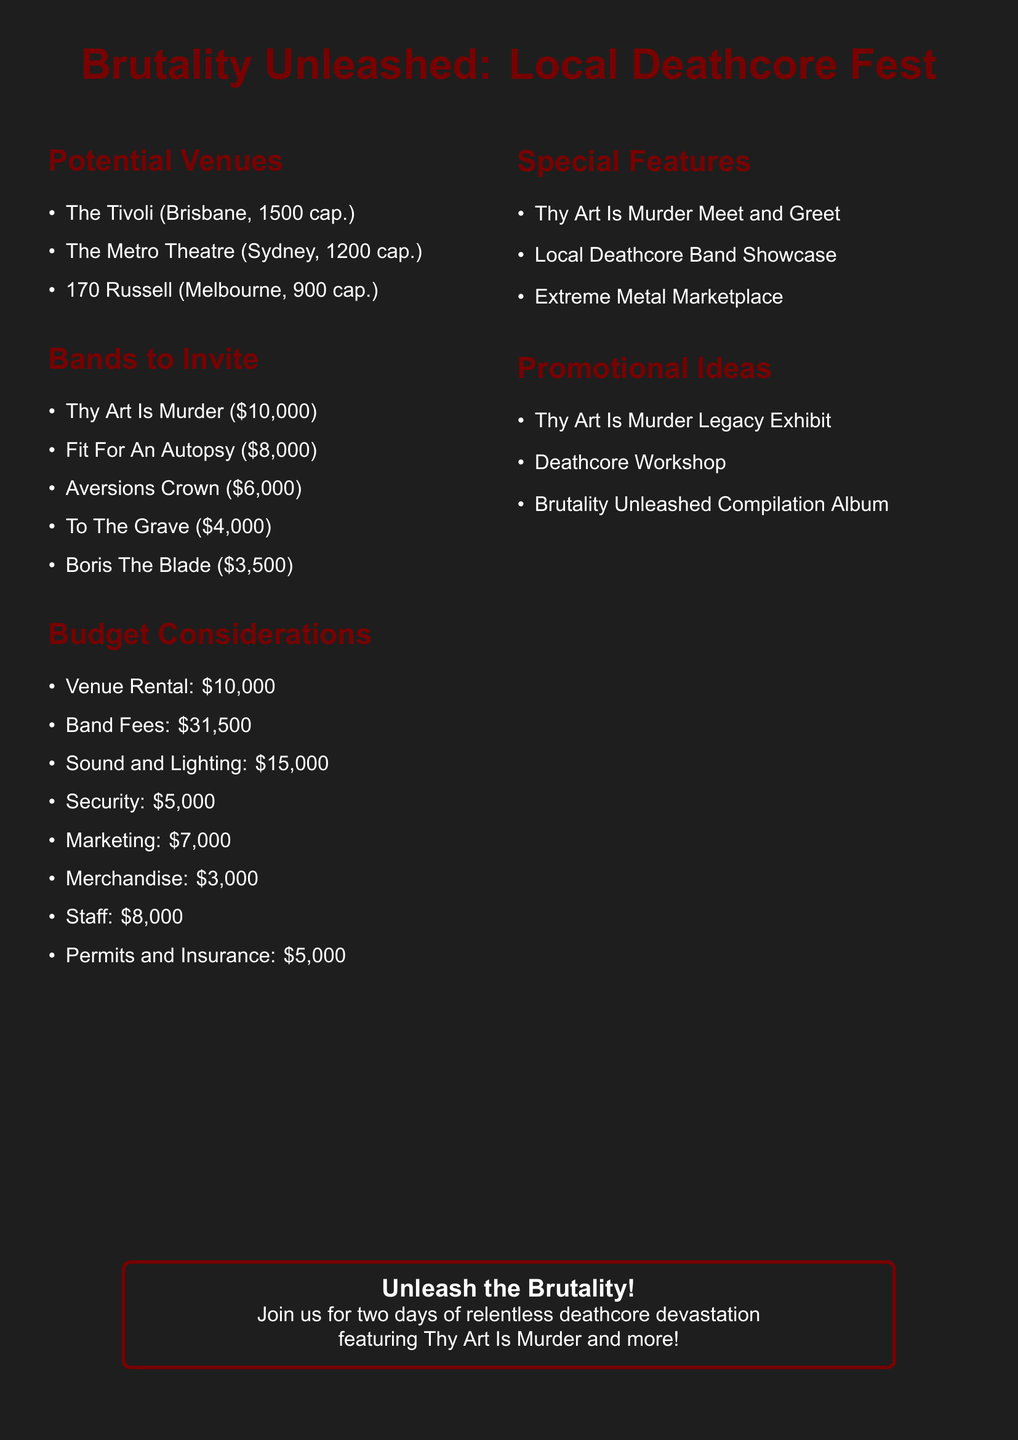What is the name of the festival? The document states the festival name is "Brutality Unleashed: Local Deathcore Fest."
Answer: Brutality Unleashed: Local Deathcore Fest How many bands are invited according to the document? The document lists five bands that are invited to the festival.
Answer: 5 What is the estimated cost of the venue rental? The budget consideration shows that the estimated cost for venue rental is $10,000.
Answer: $10,000 Which special feature is exclusive to fans? The document mentions "Thy Art Is Murder Meet and Greet" as an exclusive fan experience.
Answer: Thy Art Is Murder Meet and Greet What is the estimated fee for Thy Art Is Murder? The document lists the estimated fee for Thy Art Is Murder as $10,000.
Answer: $10,000 Which city is "The Tivoli" located in? According to the document, "The Tivoli" is located in Brisbane, Australia.
Answer: Brisbane, Australia How much is allocated for security in the budget? The budget consideration specifies that the estimated cost for security is $5,000.
Answer: $5,000 What type of event is planned for marketing? The document notes that marketing will focus on social media and the local metal scene.
Answer: Social media and local metal scene What is the total estimated fee for all invited bands? The total for all invited bands is given as $31,500 in the budget considerations.
Answer: $31,500 